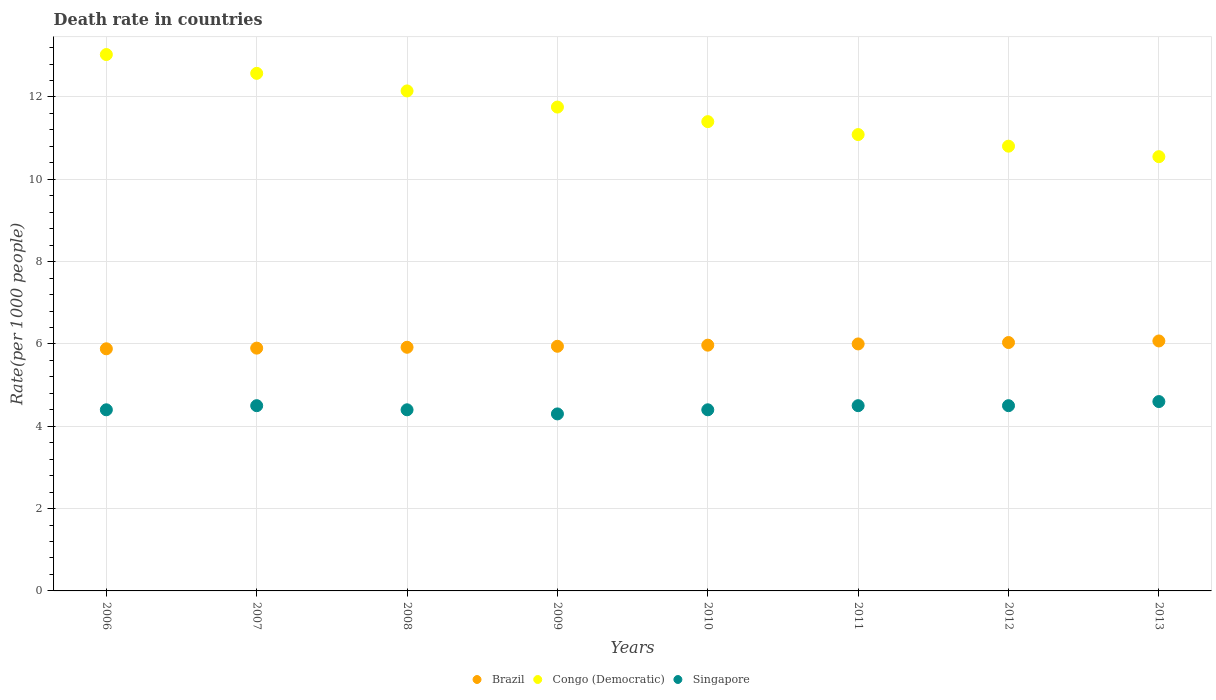How many different coloured dotlines are there?
Keep it short and to the point. 3. Is the number of dotlines equal to the number of legend labels?
Offer a terse response. Yes. What is the death rate in Singapore in 2012?
Your answer should be very brief. 4.5. Across all years, what is the maximum death rate in Congo (Democratic)?
Offer a very short reply. 13.03. Across all years, what is the minimum death rate in Brazil?
Give a very brief answer. 5.88. In which year was the death rate in Congo (Democratic) maximum?
Your answer should be very brief. 2006. What is the total death rate in Brazil in the graph?
Offer a very short reply. 47.72. What is the difference between the death rate in Brazil in 2010 and that in 2013?
Make the answer very short. -0.1. What is the difference between the death rate in Brazil in 2006 and the death rate in Congo (Democratic) in 2013?
Give a very brief answer. -4.67. What is the average death rate in Brazil per year?
Offer a very short reply. 5.96. In the year 2008, what is the difference between the death rate in Singapore and death rate in Congo (Democratic)?
Give a very brief answer. -7.75. In how many years, is the death rate in Singapore greater than 8.4?
Offer a very short reply. 0. What is the ratio of the death rate in Congo (Democratic) in 2006 to that in 2008?
Keep it short and to the point. 1.07. Is the difference between the death rate in Singapore in 2008 and 2012 greater than the difference between the death rate in Congo (Democratic) in 2008 and 2012?
Your answer should be compact. No. What is the difference between the highest and the second highest death rate in Congo (Democratic)?
Keep it short and to the point. 0.46. What is the difference between the highest and the lowest death rate in Brazil?
Ensure brevity in your answer.  0.19. Is the sum of the death rate in Congo (Democratic) in 2006 and 2009 greater than the maximum death rate in Brazil across all years?
Ensure brevity in your answer.  Yes. Does the death rate in Singapore monotonically increase over the years?
Provide a short and direct response. No. How many dotlines are there?
Make the answer very short. 3. What is the difference between two consecutive major ticks on the Y-axis?
Provide a succinct answer. 2. Where does the legend appear in the graph?
Keep it short and to the point. Bottom center. How are the legend labels stacked?
Your answer should be very brief. Horizontal. What is the title of the graph?
Offer a terse response. Death rate in countries. Does "Europe(developing only)" appear as one of the legend labels in the graph?
Ensure brevity in your answer.  No. What is the label or title of the X-axis?
Keep it short and to the point. Years. What is the label or title of the Y-axis?
Your response must be concise. Rate(per 1000 people). What is the Rate(per 1000 people) in Brazil in 2006?
Make the answer very short. 5.88. What is the Rate(per 1000 people) of Congo (Democratic) in 2006?
Your answer should be compact. 13.03. What is the Rate(per 1000 people) in Singapore in 2006?
Offer a terse response. 4.4. What is the Rate(per 1000 people) in Brazil in 2007?
Your response must be concise. 5.9. What is the Rate(per 1000 people) in Congo (Democratic) in 2007?
Provide a succinct answer. 12.57. What is the Rate(per 1000 people) of Singapore in 2007?
Your response must be concise. 4.5. What is the Rate(per 1000 people) in Brazil in 2008?
Keep it short and to the point. 5.92. What is the Rate(per 1000 people) in Congo (Democratic) in 2008?
Keep it short and to the point. 12.15. What is the Rate(per 1000 people) in Brazil in 2009?
Offer a terse response. 5.94. What is the Rate(per 1000 people) of Congo (Democratic) in 2009?
Offer a very short reply. 11.75. What is the Rate(per 1000 people) in Singapore in 2009?
Offer a very short reply. 4.3. What is the Rate(per 1000 people) in Brazil in 2010?
Your answer should be very brief. 5.97. What is the Rate(per 1000 people) of Congo (Democratic) in 2010?
Your answer should be compact. 11.4. What is the Rate(per 1000 people) in Singapore in 2010?
Ensure brevity in your answer.  4.4. What is the Rate(per 1000 people) of Congo (Democratic) in 2011?
Ensure brevity in your answer.  11.09. What is the Rate(per 1000 people) of Singapore in 2011?
Your response must be concise. 4.5. What is the Rate(per 1000 people) of Brazil in 2012?
Keep it short and to the point. 6.03. What is the Rate(per 1000 people) of Congo (Democratic) in 2012?
Make the answer very short. 10.8. What is the Rate(per 1000 people) of Brazil in 2013?
Provide a short and direct response. 6.07. What is the Rate(per 1000 people) in Congo (Democratic) in 2013?
Provide a short and direct response. 10.55. Across all years, what is the maximum Rate(per 1000 people) in Brazil?
Give a very brief answer. 6.07. Across all years, what is the maximum Rate(per 1000 people) in Congo (Democratic)?
Give a very brief answer. 13.03. Across all years, what is the minimum Rate(per 1000 people) in Brazil?
Make the answer very short. 5.88. Across all years, what is the minimum Rate(per 1000 people) of Congo (Democratic)?
Your response must be concise. 10.55. Across all years, what is the minimum Rate(per 1000 people) of Singapore?
Offer a very short reply. 4.3. What is the total Rate(per 1000 people) in Brazil in the graph?
Ensure brevity in your answer.  47.72. What is the total Rate(per 1000 people) in Congo (Democratic) in the graph?
Offer a terse response. 93.34. What is the total Rate(per 1000 people) of Singapore in the graph?
Offer a terse response. 35.6. What is the difference between the Rate(per 1000 people) of Brazil in 2006 and that in 2007?
Offer a terse response. -0.02. What is the difference between the Rate(per 1000 people) in Congo (Democratic) in 2006 and that in 2007?
Make the answer very short. 0.46. What is the difference between the Rate(per 1000 people) of Brazil in 2006 and that in 2008?
Your answer should be very brief. -0.04. What is the difference between the Rate(per 1000 people) in Congo (Democratic) in 2006 and that in 2008?
Your answer should be very brief. 0.88. What is the difference between the Rate(per 1000 people) in Brazil in 2006 and that in 2009?
Offer a very short reply. -0.06. What is the difference between the Rate(per 1000 people) in Congo (Democratic) in 2006 and that in 2009?
Keep it short and to the point. 1.28. What is the difference between the Rate(per 1000 people) of Brazil in 2006 and that in 2010?
Your response must be concise. -0.09. What is the difference between the Rate(per 1000 people) in Congo (Democratic) in 2006 and that in 2010?
Provide a succinct answer. 1.63. What is the difference between the Rate(per 1000 people) of Brazil in 2006 and that in 2011?
Give a very brief answer. -0.12. What is the difference between the Rate(per 1000 people) in Congo (Democratic) in 2006 and that in 2011?
Your answer should be very brief. 1.94. What is the difference between the Rate(per 1000 people) in Brazil in 2006 and that in 2012?
Your answer should be compact. -0.15. What is the difference between the Rate(per 1000 people) in Congo (Democratic) in 2006 and that in 2012?
Ensure brevity in your answer.  2.23. What is the difference between the Rate(per 1000 people) of Singapore in 2006 and that in 2012?
Offer a terse response. -0.1. What is the difference between the Rate(per 1000 people) in Brazil in 2006 and that in 2013?
Give a very brief answer. -0.19. What is the difference between the Rate(per 1000 people) in Congo (Democratic) in 2006 and that in 2013?
Provide a short and direct response. 2.48. What is the difference between the Rate(per 1000 people) in Brazil in 2007 and that in 2008?
Give a very brief answer. -0.02. What is the difference between the Rate(per 1000 people) of Congo (Democratic) in 2007 and that in 2008?
Provide a succinct answer. 0.43. What is the difference between the Rate(per 1000 people) in Brazil in 2007 and that in 2009?
Give a very brief answer. -0.04. What is the difference between the Rate(per 1000 people) of Congo (Democratic) in 2007 and that in 2009?
Provide a succinct answer. 0.82. What is the difference between the Rate(per 1000 people) of Singapore in 2007 and that in 2009?
Give a very brief answer. 0.2. What is the difference between the Rate(per 1000 people) of Brazil in 2007 and that in 2010?
Ensure brevity in your answer.  -0.07. What is the difference between the Rate(per 1000 people) in Congo (Democratic) in 2007 and that in 2010?
Ensure brevity in your answer.  1.17. What is the difference between the Rate(per 1000 people) in Singapore in 2007 and that in 2010?
Make the answer very short. 0.1. What is the difference between the Rate(per 1000 people) of Brazil in 2007 and that in 2011?
Ensure brevity in your answer.  -0.1. What is the difference between the Rate(per 1000 people) of Congo (Democratic) in 2007 and that in 2011?
Your answer should be very brief. 1.49. What is the difference between the Rate(per 1000 people) of Singapore in 2007 and that in 2011?
Your answer should be compact. 0. What is the difference between the Rate(per 1000 people) of Brazil in 2007 and that in 2012?
Your answer should be compact. -0.14. What is the difference between the Rate(per 1000 people) in Congo (Democratic) in 2007 and that in 2012?
Ensure brevity in your answer.  1.77. What is the difference between the Rate(per 1000 people) of Brazil in 2007 and that in 2013?
Provide a succinct answer. -0.17. What is the difference between the Rate(per 1000 people) in Congo (Democratic) in 2007 and that in 2013?
Ensure brevity in your answer.  2.02. What is the difference between the Rate(per 1000 people) in Brazil in 2008 and that in 2009?
Your answer should be compact. -0.02. What is the difference between the Rate(per 1000 people) in Congo (Democratic) in 2008 and that in 2009?
Give a very brief answer. 0.39. What is the difference between the Rate(per 1000 people) in Singapore in 2008 and that in 2009?
Offer a terse response. 0.1. What is the difference between the Rate(per 1000 people) in Brazil in 2008 and that in 2010?
Give a very brief answer. -0.05. What is the difference between the Rate(per 1000 people) in Congo (Democratic) in 2008 and that in 2010?
Give a very brief answer. 0.75. What is the difference between the Rate(per 1000 people) in Brazil in 2008 and that in 2011?
Your response must be concise. -0.08. What is the difference between the Rate(per 1000 people) of Congo (Democratic) in 2008 and that in 2011?
Your response must be concise. 1.06. What is the difference between the Rate(per 1000 people) of Singapore in 2008 and that in 2011?
Your answer should be compact. -0.1. What is the difference between the Rate(per 1000 people) in Brazil in 2008 and that in 2012?
Your response must be concise. -0.12. What is the difference between the Rate(per 1000 people) of Congo (Democratic) in 2008 and that in 2012?
Offer a terse response. 1.34. What is the difference between the Rate(per 1000 people) of Brazil in 2008 and that in 2013?
Offer a terse response. -0.15. What is the difference between the Rate(per 1000 people) of Congo (Democratic) in 2008 and that in 2013?
Offer a terse response. 1.6. What is the difference between the Rate(per 1000 people) in Brazil in 2009 and that in 2010?
Offer a very short reply. -0.03. What is the difference between the Rate(per 1000 people) in Congo (Democratic) in 2009 and that in 2010?
Offer a very short reply. 0.35. What is the difference between the Rate(per 1000 people) in Brazil in 2009 and that in 2011?
Provide a succinct answer. -0.06. What is the difference between the Rate(per 1000 people) in Congo (Democratic) in 2009 and that in 2011?
Provide a short and direct response. 0.67. What is the difference between the Rate(per 1000 people) in Singapore in 2009 and that in 2011?
Offer a very short reply. -0.2. What is the difference between the Rate(per 1000 people) in Brazil in 2009 and that in 2012?
Provide a succinct answer. -0.09. What is the difference between the Rate(per 1000 people) in Singapore in 2009 and that in 2012?
Your answer should be compact. -0.2. What is the difference between the Rate(per 1000 people) of Brazil in 2009 and that in 2013?
Ensure brevity in your answer.  -0.13. What is the difference between the Rate(per 1000 people) of Congo (Democratic) in 2009 and that in 2013?
Your answer should be very brief. 1.21. What is the difference between the Rate(per 1000 people) of Singapore in 2009 and that in 2013?
Keep it short and to the point. -0.3. What is the difference between the Rate(per 1000 people) in Brazil in 2010 and that in 2011?
Keep it short and to the point. -0.03. What is the difference between the Rate(per 1000 people) in Congo (Democratic) in 2010 and that in 2011?
Offer a terse response. 0.31. What is the difference between the Rate(per 1000 people) of Brazil in 2010 and that in 2012?
Provide a succinct answer. -0.06. What is the difference between the Rate(per 1000 people) in Congo (Democratic) in 2010 and that in 2012?
Your answer should be very brief. 0.6. What is the difference between the Rate(per 1000 people) in Singapore in 2010 and that in 2012?
Make the answer very short. -0.1. What is the difference between the Rate(per 1000 people) in Brazil in 2010 and that in 2013?
Offer a very short reply. -0.1. What is the difference between the Rate(per 1000 people) of Congo (Democratic) in 2010 and that in 2013?
Offer a terse response. 0.85. What is the difference between the Rate(per 1000 people) in Brazil in 2011 and that in 2012?
Provide a succinct answer. -0.03. What is the difference between the Rate(per 1000 people) in Congo (Democratic) in 2011 and that in 2012?
Provide a short and direct response. 0.28. What is the difference between the Rate(per 1000 people) of Singapore in 2011 and that in 2012?
Your response must be concise. 0. What is the difference between the Rate(per 1000 people) of Brazil in 2011 and that in 2013?
Keep it short and to the point. -0.07. What is the difference between the Rate(per 1000 people) in Congo (Democratic) in 2011 and that in 2013?
Your answer should be very brief. 0.54. What is the difference between the Rate(per 1000 people) in Singapore in 2011 and that in 2013?
Give a very brief answer. -0.1. What is the difference between the Rate(per 1000 people) of Brazil in 2012 and that in 2013?
Provide a succinct answer. -0.04. What is the difference between the Rate(per 1000 people) of Congo (Democratic) in 2012 and that in 2013?
Provide a short and direct response. 0.26. What is the difference between the Rate(per 1000 people) of Singapore in 2012 and that in 2013?
Provide a short and direct response. -0.1. What is the difference between the Rate(per 1000 people) in Brazil in 2006 and the Rate(per 1000 people) in Congo (Democratic) in 2007?
Provide a succinct answer. -6.69. What is the difference between the Rate(per 1000 people) in Brazil in 2006 and the Rate(per 1000 people) in Singapore in 2007?
Give a very brief answer. 1.38. What is the difference between the Rate(per 1000 people) of Congo (Democratic) in 2006 and the Rate(per 1000 people) of Singapore in 2007?
Provide a succinct answer. 8.53. What is the difference between the Rate(per 1000 people) in Brazil in 2006 and the Rate(per 1000 people) in Congo (Democratic) in 2008?
Offer a very short reply. -6.26. What is the difference between the Rate(per 1000 people) in Brazil in 2006 and the Rate(per 1000 people) in Singapore in 2008?
Provide a succinct answer. 1.48. What is the difference between the Rate(per 1000 people) of Congo (Democratic) in 2006 and the Rate(per 1000 people) of Singapore in 2008?
Offer a very short reply. 8.63. What is the difference between the Rate(per 1000 people) of Brazil in 2006 and the Rate(per 1000 people) of Congo (Democratic) in 2009?
Offer a very short reply. -5.87. What is the difference between the Rate(per 1000 people) of Brazil in 2006 and the Rate(per 1000 people) of Singapore in 2009?
Your answer should be compact. 1.58. What is the difference between the Rate(per 1000 people) in Congo (Democratic) in 2006 and the Rate(per 1000 people) in Singapore in 2009?
Your answer should be compact. 8.73. What is the difference between the Rate(per 1000 people) in Brazil in 2006 and the Rate(per 1000 people) in Congo (Democratic) in 2010?
Your response must be concise. -5.52. What is the difference between the Rate(per 1000 people) of Brazil in 2006 and the Rate(per 1000 people) of Singapore in 2010?
Make the answer very short. 1.48. What is the difference between the Rate(per 1000 people) in Congo (Democratic) in 2006 and the Rate(per 1000 people) in Singapore in 2010?
Your answer should be compact. 8.63. What is the difference between the Rate(per 1000 people) in Brazil in 2006 and the Rate(per 1000 people) in Congo (Democratic) in 2011?
Offer a very short reply. -5.2. What is the difference between the Rate(per 1000 people) in Brazil in 2006 and the Rate(per 1000 people) in Singapore in 2011?
Keep it short and to the point. 1.38. What is the difference between the Rate(per 1000 people) in Congo (Democratic) in 2006 and the Rate(per 1000 people) in Singapore in 2011?
Provide a succinct answer. 8.53. What is the difference between the Rate(per 1000 people) of Brazil in 2006 and the Rate(per 1000 people) of Congo (Democratic) in 2012?
Ensure brevity in your answer.  -4.92. What is the difference between the Rate(per 1000 people) of Brazil in 2006 and the Rate(per 1000 people) of Singapore in 2012?
Give a very brief answer. 1.38. What is the difference between the Rate(per 1000 people) of Congo (Democratic) in 2006 and the Rate(per 1000 people) of Singapore in 2012?
Offer a terse response. 8.53. What is the difference between the Rate(per 1000 people) of Brazil in 2006 and the Rate(per 1000 people) of Congo (Democratic) in 2013?
Your answer should be compact. -4.67. What is the difference between the Rate(per 1000 people) of Brazil in 2006 and the Rate(per 1000 people) of Singapore in 2013?
Provide a short and direct response. 1.28. What is the difference between the Rate(per 1000 people) of Congo (Democratic) in 2006 and the Rate(per 1000 people) of Singapore in 2013?
Your response must be concise. 8.43. What is the difference between the Rate(per 1000 people) of Brazil in 2007 and the Rate(per 1000 people) of Congo (Democratic) in 2008?
Offer a terse response. -6.25. What is the difference between the Rate(per 1000 people) in Brazil in 2007 and the Rate(per 1000 people) in Singapore in 2008?
Provide a short and direct response. 1.5. What is the difference between the Rate(per 1000 people) in Congo (Democratic) in 2007 and the Rate(per 1000 people) in Singapore in 2008?
Your answer should be compact. 8.17. What is the difference between the Rate(per 1000 people) of Brazil in 2007 and the Rate(per 1000 people) of Congo (Democratic) in 2009?
Give a very brief answer. -5.86. What is the difference between the Rate(per 1000 people) in Brazil in 2007 and the Rate(per 1000 people) in Singapore in 2009?
Offer a terse response. 1.6. What is the difference between the Rate(per 1000 people) of Congo (Democratic) in 2007 and the Rate(per 1000 people) of Singapore in 2009?
Offer a very short reply. 8.27. What is the difference between the Rate(per 1000 people) of Brazil in 2007 and the Rate(per 1000 people) of Congo (Democratic) in 2010?
Offer a very short reply. -5.5. What is the difference between the Rate(per 1000 people) of Brazil in 2007 and the Rate(per 1000 people) of Singapore in 2010?
Provide a succinct answer. 1.5. What is the difference between the Rate(per 1000 people) of Congo (Democratic) in 2007 and the Rate(per 1000 people) of Singapore in 2010?
Offer a terse response. 8.17. What is the difference between the Rate(per 1000 people) of Brazil in 2007 and the Rate(per 1000 people) of Congo (Democratic) in 2011?
Keep it short and to the point. -5.19. What is the difference between the Rate(per 1000 people) of Brazil in 2007 and the Rate(per 1000 people) of Singapore in 2011?
Provide a succinct answer. 1.4. What is the difference between the Rate(per 1000 people) in Congo (Democratic) in 2007 and the Rate(per 1000 people) in Singapore in 2011?
Provide a short and direct response. 8.07. What is the difference between the Rate(per 1000 people) of Brazil in 2007 and the Rate(per 1000 people) of Congo (Democratic) in 2012?
Your answer should be very brief. -4.91. What is the difference between the Rate(per 1000 people) of Brazil in 2007 and the Rate(per 1000 people) of Singapore in 2012?
Give a very brief answer. 1.4. What is the difference between the Rate(per 1000 people) in Congo (Democratic) in 2007 and the Rate(per 1000 people) in Singapore in 2012?
Make the answer very short. 8.07. What is the difference between the Rate(per 1000 people) in Brazil in 2007 and the Rate(per 1000 people) in Congo (Democratic) in 2013?
Ensure brevity in your answer.  -4.65. What is the difference between the Rate(per 1000 people) of Brazil in 2007 and the Rate(per 1000 people) of Singapore in 2013?
Provide a short and direct response. 1.3. What is the difference between the Rate(per 1000 people) of Congo (Democratic) in 2007 and the Rate(per 1000 people) of Singapore in 2013?
Ensure brevity in your answer.  7.97. What is the difference between the Rate(per 1000 people) of Brazil in 2008 and the Rate(per 1000 people) of Congo (Democratic) in 2009?
Ensure brevity in your answer.  -5.83. What is the difference between the Rate(per 1000 people) of Brazil in 2008 and the Rate(per 1000 people) of Singapore in 2009?
Offer a very short reply. 1.62. What is the difference between the Rate(per 1000 people) in Congo (Democratic) in 2008 and the Rate(per 1000 people) in Singapore in 2009?
Offer a very short reply. 7.85. What is the difference between the Rate(per 1000 people) of Brazil in 2008 and the Rate(per 1000 people) of Congo (Democratic) in 2010?
Provide a succinct answer. -5.48. What is the difference between the Rate(per 1000 people) in Brazil in 2008 and the Rate(per 1000 people) in Singapore in 2010?
Provide a succinct answer. 1.52. What is the difference between the Rate(per 1000 people) in Congo (Democratic) in 2008 and the Rate(per 1000 people) in Singapore in 2010?
Your answer should be very brief. 7.75. What is the difference between the Rate(per 1000 people) in Brazil in 2008 and the Rate(per 1000 people) in Congo (Democratic) in 2011?
Your answer should be compact. -5.17. What is the difference between the Rate(per 1000 people) in Brazil in 2008 and the Rate(per 1000 people) in Singapore in 2011?
Provide a succinct answer. 1.42. What is the difference between the Rate(per 1000 people) in Congo (Democratic) in 2008 and the Rate(per 1000 people) in Singapore in 2011?
Offer a terse response. 7.65. What is the difference between the Rate(per 1000 people) in Brazil in 2008 and the Rate(per 1000 people) in Congo (Democratic) in 2012?
Your answer should be very brief. -4.88. What is the difference between the Rate(per 1000 people) in Brazil in 2008 and the Rate(per 1000 people) in Singapore in 2012?
Keep it short and to the point. 1.42. What is the difference between the Rate(per 1000 people) of Congo (Democratic) in 2008 and the Rate(per 1000 people) of Singapore in 2012?
Your answer should be compact. 7.65. What is the difference between the Rate(per 1000 people) of Brazil in 2008 and the Rate(per 1000 people) of Congo (Democratic) in 2013?
Your answer should be very brief. -4.63. What is the difference between the Rate(per 1000 people) of Brazil in 2008 and the Rate(per 1000 people) of Singapore in 2013?
Give a very brief answer. 1.32. What is the difference between the Rate(per 1000 people) of Congo (Democratic) in 2008 and the Rate(per 1000 people) of Singapore in 2013?
Your response must be concise. 7.55. What is the difference between the Rate(per 1000 people) in Brazil in 2009 and the Rate(per 1000 people) in Congo (Democratic) in 2010?
Your answer should be very brief. -5.46. What is the difference between the Rate(per 1000 people) of Brazil in 2009 and the Rate(per 1000 people) of Singapore in 2010?
Your response must be concise. 1.54. What is the difference between the Rate(per 1000 people) of Congo (Democratic) in 2009 and the Rate(per 1000 people) of Singapore in 2010?
Provide a succinct answer. 7.35. What is the difference between the Rate(per 1000 people) of Brazil in 2009 and the Rate(per 1000 people) of Congo (Democratic) in 2011?
Offer a very short reply. -5.14. What is the difference between the Rate(per 1000 people) in Brazil in 2009 and the Rate(per 1000 people) in Singapore in 2011?
Ensure brevity in your answer.  1.44. What is the difference between the Rate(per 1000 people) of Congo (Democratic) in 2009 and the Rate(per 1000 people) of Singapore in 2011?
Offer a terse response. 7.25. What is the difference between the Rate(per 1000 people) in Brazil in 2009 and the Rate(per 1000 people) in Congo (Democratic) in 2012?
Offer a very short reply. -4.86. What is the difference between the Rate(per 1000 people) in Brazil in 2009 and the Rate(per 1000 people) in Singapore in 2012?
Ensure brevity in your answer.  1.44. What is the difference between the Rate(per 1000 people) of Congo (Democratic) in 2009 and the Rate(per 1000 people) of Singapore in 2012?
Provide a succinct answer. 7.25. What is the difference between the Rate(per 1000 people) in Brazil in 2009 and the Rate(per 1000 people) in Congo (Democratic) in 2013?
Your answer should be very brief. -4.61. What is the difference between the Rate(per 1000 people) of Brazil in 2009 and the Rate(per 1000 people) of Singapore in 2013?
Your response must be concise. 1.34. What is the difference between the Rate(per 1000 people) in Congo (Democratic) in 2009 and the Rate(per 1000 people) in Singapore in 2013?
Offer a very short reply. 7.15. What is the difference between the Rate(per 1000 people) in Brazil in 2010 and the Rate(per 1000 people) in Congo (Democratic) in 2011?
Make the answer very short. -5.12. What is the difference between the Rate(per 1000 people) of Brazil in 2010 and the Rate(per 1000 people) of Singapore in 2011?
Your answer should be very brief. 1.47. What is the difference between the Rate(per 1000 people) of Brazil in 2010 and the Rate(per 1000 people) of Congo (Democratic) in 2012?
Your answer should be compact. -4.83. What is the difference between the Rate(per 1000 people) of Brazil in 2010 and the Rate(per 1000 people) of Singapore in 2012?
Your answer should be very brief. 1.47. What is the difference between the Rate(per 1000 people) in Brazil in 2010 and the Rate(per 1000 people) in Congo (Democratic) in 2013?
Your answer should be compact. -4.58. What is the difference between the Rate(per 1000 people) in Brazil in 2010 and the Rate(per 1000 people) in Singapore in 2013?
Provide a short and direct response. 1.37. What is the difference between the Rate(per 1000 people) of Congo (Democratic) in 2010 and the Rate(per 1000 people) of Singapore in 2013?
Provide a short and direct response. 6.8. What is the difference between the Rate(per 1000 people) of Brazil in 2011 and the Rate(per 1000 people) of Congo (Democratic) in 2012?
Your answer should be compact. -4.8. What is the difference between the Rate(per 1000 people) in Congo (Democratic) in 2011 and the Rate(per 1000 people) in Singapore in 2012?
Ensure brevity in your answer.  6.59. What is the difference between the Rate(per 1000 people) of Brazil in 2011 and the Rate(per 1000 people) of Congo (Democratic) in 2013?
Provide a short and direct response. -4.55. What is the difference between the Rate(per 1000 people) of Congo (Democratic) in 2011 and the Rate(per 1000 people) of Singapore in 2013?
Ensure brevity in your answer.  6.49. What is the difference between the Rate(per 1000 people) of Brazil in 2012 and the Rate(per 1000 people) of Congo (Democratic) in 2013?
Offer a very short reply. -4.51. What is the difference between the Rate(per 1000 people) of Brazil in 2012 and the Rate(per 1000 people) of Singapore in 2013?
Make the answer very short. 1.43. What is the difference between the Rate(per 1000 people) in Congo (Democratic) in 2012 and the Rate(per 1000 people) in Singapore in 2013?
Your answer should be very brief. 6.2. What is the average Rate(per 1000 people) in Brazil per year?
Give a very brief answer. 5.96. What is the average Rate(per 1000 people) of Congo (Democratic) per year?
Ensure brevity in your answer.  11.67. What is the average Rate(per 1000 people) of Singapore per year?
Give a very brief answer. 4.45. In the year 2006, what is the difference between the Rate(per 1000 people) of Brazil and Rate(per 1000 people) of Congo (Democratic)?
Give a very brief answer. -7.15. In the year 2006, what is the difference between the Rate(per 1000 people) in Brazil and Rate(per 1000 people) in Singapore?
Make the answer very short. 1.48. In the year 2006, what is the difference between the Rate(per 1000 people) in Congo (Democratic) and Rate(per 1000 people) in Singapore?
Keep it short and to the point. 8.63. In the year 2007, what is the difference between the Rate(per 1000 people) of Brazil and Rate(per 1000 people) of Congo (Democratic)?
Provide a short and direct response. -6.67. In the year 2007, what is the difference between the Rate(per 1000 people) in Brazil and Rate(per 1000 people) in Singapore?
Your response must be concise. 1.4. In the year 2007, what is the difference between the Rate(per 1000 people) of Congo (Democratic) and Rate(per 1000 people) of Singapore?
Give a very brief answer. 8.07. In the year 2008, what is the difference between the Rate(per 1000 people) of Brazil and Rate(per 1000 people) of Congo (Democratic)?
Offer a very short reply. -6.23. In the year 2008, what is the difference between the Rate(per 1000 people) of Brazil and Rate(per 1000 people) of Singapore?
Provide a succinct answer. 1.52. In the year 2008, what is the difference between the Rate(per 1000 people) of Congo (Democratic) and Rate(per 1000 people) of Singapore?
Keep it short and to the point. 7.75. In the year 2009, what is the difference between the Rate(per 1000 people) in Brazil and Rate(per 1000 people) in Congo (Democratic)?
Offer a very short reply. -5.81. In the year 2009, what is the difference between the Rate(per 1000 people) in Brazil and Rate(per 1000 people) in Singapore?
Your response must be concise. 1.64. In the year 2009, what is the difference between the Rate(per 1000 people) of Congo (Democratic) and Rate(per 1000 people) of Singapore?
Your response must be concise. 7.45. In the year 2010, what is the difference between the Rate(per 1000 people) in Brazil and Rate(per 1000 people) in Congo (Democratic)?
Your answer should be compact. -5.43. In the year 2010, what is the difference between the Rate(per 1000 people) of Brazil and Rate(per 1000 people) of Singapore?
Give a very brief answer. 1.57. In the year 2010, what is the difference between the Rate(per 1000 people) of Congo (Democratic) and Rate(per 1000 people) of Singapore?
Offer a terse response. 7. In the year 2011, what is the difference between the Rate(per 1000 people) in Brazil and Rate(per 1000 people) in Congo (Democratic)?
Your answer should be compact. -5.09. In the year 2011, what is the difference between the Rate(per 1000 people) in Brazil and Rate(per 1000 people) in Singapore?
Make the answer very short. 1.5. In the year 2011, what is the difference between the Rate(per 1000 people) in Congo (Democratic) and Rate(per 1000 people) in Singapore?
Your response must be concise. 6.59. In the year 2012, what is the difference between the Rate(per 1000 people) of Brazil and Rate(per 1000 people) of Congo (Democratic)?
Offer a terse response. -4.77. In the year 2012, what is the difference between the Rate(per 1000 people) of Brazil and Rate(per 1000 people) of Singapore?
Your answer should be very brief. 1.53. In the year 2012, what is the difference between the Rate(per 1000 people) of Congo (Democratic) and Rate(per 1000 people) of Singapore?
Provide a short and direct response. 6.3. In the year 2013, what is the difference between the Rate(per 1000 people) in Brazil and Rate(per 1000 people) in Congo (Democratic)?
Offer a terse response. -4.48. In the year 2013, what is the difference between the Rate(per 1000 people) in Brazil and Rate(per 1000 people) in Singapore?
Ensure brevity in your answer.  1.47. In the year 2013, what is the difference between the Rate(per 1000 people) in Congo (Democratic) and Rate(per 1000 people) in Singapore?
Your answer should be very brief. 5.95. What is the ratio of the Rate(per 1000 people) in Brazil in 2006 to that in 2007?
Ensure brevity in your answer.  1. What is the ratio of the Rate(per 1000 people) of Congo (Democratic) in 2006 to that in 2007?
Provide a succinct answer. 1.04. What is the ratio of the Rate(per 1000 people) in Singapore in 2006 to that in 2007?
Your answer should be compact. 0.98. What is the ratio of the Rate(per 1000 people) in Congo (Democratic) in 2006 to that in 2008?
Make the answer very short. 1.07. What is the ratio of the Rate(per 1000 people) of Brazil in 2006 to that in 2009?
Your response must be concise. 0.99. What is the ratio of the Rate(per 1000 people) of Congo (Democratic) in 2006 to that in 2009?
Ensure brevity in your answer.  1.11. What is the ratio of the Rate(per 1000 people) of Singapore in 2006 to that in 2009?
Your response must be concise. 1.02. What is the ratio of the Rate(per 1000 people) in Brazil in 2006 to that in 2010?
Your response must be concise. 0.99. What is the ratio of the Rate(per 1000 people) in Congo (Democratic) in 2006 to that in 2010?
Your answer should be compact. 1.14. What is the ratio of the Rate(per 1000 people) in Singapore in 2006 to that in 2010?
Give a very brief answer. 1. What is the ratio of the Rate(per 1000 people) of Brazil in 2006 to that in 2011?
Offer a very short reply. 0.98. What is the ratio of the Rate(per 1000 people) in Congo (Democratic) in 2006 to that in 2011?
Make the answer very short. 1.18. What is the ratio of the Rate(per 1000 people) in Singapore in 2006 to that in 2011?
Your answer should be very brief. 0.98. What is the ratio of the Rate(per 1000 people) of Brazil in 2006 to that in 2012?
Your response must be concise. 0.97. What is the ratio of the Rate(per 1000 people) of Congo (Democratic) in 2006 to that in 2012?
Make the answer very short. 1.21. What is the ratio of the Rate(per 1000 people) of Singapore in 2006 to that in 2012?
Offer a very short reply. 0.98. What is the ratio of the Rate(per 1000 people) of Brazil in 2006 to that in 2013?
Provide a succinct answer. 0.97. What is the ratio of the Rate(per 1000 people) of Congo (Democratic) in 2006 to that in 2013?
Make the answer very short. 1.24. What is the ratio of the Rate(per 1000 people) of Singapore in 2006 to that in 2013?
Offer a very short reply. 0.96. What is the ratio of the Rate(per 1000 people) of Congo (Democratic) in 2007 to that in 2008?
Give a very brief answer. 1.04. What is the ratio of the Rate(per 1000 people) in Singapore in 2007 to that in 2008?
Offer a terse response. 1.02. What is the ratio of the Rate(per 1000 people) in Congo (Democratic) in 2007 to that in 2009?
Your answer should be very brief. 1.07. What is the ratio of the Rate(per 1000 people) in Singapore in 2007 to that in 2009?
Keep it short and to the point. 1.05. What is the ratio of the Rate(per 1000 people) in Brazil in 2007 to that in 2010?
Provide a succinct answer. 0.99. What is the ratio of the Rate(per 1000 people) of Congo (Democratic) in 2007 to that in 2010?
Give a very brief answer. 1.1. What is the ratio of the Rate(per 1000 people) in Singapore in 2007 to that in 2010?
Provide a succinct answer. 1.02. What is the ratio of the Rate(per 1000 people) of Brazil in 2007 to that in 2011?
Offer a very short reply. 0.98. What is the ratio of the Rate(per 1000 people) of Congo (Democratic) in 2007 to that in 2011?
Provide a succinct answer. 1.13. What is the ratio of the Rate(per 1000 people) of Brazil in 2007 to that in 2012?
Provide a succinct answer. 0.98. What is the ratio of the Rate(per 1000 people) in Congo (Democratic) in 2007 to that in 2012?
Provide a short and direct response. 1.16. What is the ratio of the Rate(per 1000 people) of Brazil in 2007 to that in 2013?
Ensure brevity in your answer.  0.97. What is the ratio of the Rate(per 1000 people) in Congo (Democratic) in 2007 to that in 2013?
Give a very brief answer. 1.19. What is the ratio of the Rate(per 1000 people) in Singapore in 2007 to that in 2013?
Give a very brief answer. 0.98. What is the ratio of the Rate(per 1000 people) of Brazil in 2008 to that in 2009?
Offer a very short reply. 1. What is the ratio of the Rate(per 1000 people) in Congo (Democratic) in 2008 to that in 2009?
Make the answer very short. 1.03. What is the ratio of the Rate(per 1000 people) in Singapore in 2008 to that in 2009?
Your answer should be very brief. 1.02. What is the ratio of the Rate(per 1000 people) in Brazil in 2008 to that in 2010?
Provide a succinct answer. 0.99. What is the ratio of the Rate(per 1000 people) of Congo (Democratic) in 2008 to that in 2010?
Make the answer very short. 1.07. What is the ratio of the Rate(per 1000 people) of Singapore in 2008 to that in 2010?
Your response must be concise. 1. What is the ratio of the Rate(per 1000 people) in Brazil in 2008 to that in 2011?
Your answer should be very brief. 0.99. What is the ratio of the Rate(per 1000 people) in Congo (Democratic) in 2008 to that in 2011?
Your response must be concise. 1.1. What is the ratio of the Rate(per 1000 people) of Singapore in 2008 to that in 2011?
Your answer should be very brief. 0.98. What is the ratio of the Rate(per 1000 people) of Brazil in 2008 to that in 2012?
Ensure brevity in your answer.  0.98. What is the ratio of the Rate(per 1000 people) in Congo (Democratic) in 2008 to that in 2012?
Ensure brevity in your answer.  1.12. What is the ratio of the Rate(per 1000 people) of Singapore in 2008 to that in 2012?
Your answer should be compact. 0.98. What is the ratio of the Rate(per 1000 people) of Brazil in 2008 to that in 2013?
Make the answer very short. 0.97. What is the ratio of the Rate(per 1000 people) of Congo (Democratic) in 2008 to that in 2013?
Keep it short and to the point. 1.15. What is the ratio of the Rate(per 1000 people) in Singapore in 2008 to that in 2013?
Make the answer very short. 0.96. What is the ratio of the Rate(per 1000 people) in Congo (Democratic) in 2009 to that in 2010?
Ensure brevity in your answer.  1.03. What is the ratio of the Rate(per 1000 people) in Singapore in 2009 to that in 2010?
Your response must be concise. 0.98. What is the ratio of the Rate(per 1000 people) of Congo (Democratic) in 2009 to that in 2011?
Offer a very short reply. 1.06. What is the ratio of the Rate(per 1000 people) of Singapore in 2009 to that in 2011?
Your response must be concise. 0.96. What is the ratio of the Rate(per 1000 people) in Brazil in 2009 to that in 2012?
Your answer should be compact. 0.98. What is the ratio of the Rate(per 1000 people) in Congo (Democratic) in 2009 to that in 2012?
Offer a very short reply. 1.09. What is the ratio of the Rate(per 1000 people) of Singapore in 2009 to that in 2012?
Your answer should be compact. 0.96. What is the ratio of the Rate(per 1000 people) in Brazil in 2009 to that in 2013?
Make the answer very short. 0.98. What is the ratio of the Rate(per 1000 people) in Congo (Democratic) in 2009 to that in 2013?
Provide a succinct answer. 1.11. What is the ratio of the Rate(per 1000 people) of Singapore in 2009 to that in 2013?
Offer a very short reply. 0.93. What is the ratio of the Rate(per 1000 people) of Congo (Democratic) in 2010 to that in 2011?
Offer a very short reply. 1.03. What is the ratio of the Rate(per 1000 people) in Singapore in 2010 to that in 2011?
Provide a short and direct response. 0.98. What is the ratio of the Rate(per 1000 people) of Brazil in 2010 to that in 2012?
Give a very brief answer. 0.99. What is the ratio of the Rate(per 1000 people) of Congo (Democratic) in 2010 to that in 2012?
Your answer should be compact. 1.06. What is the ratio of the Rate(per 1000 people) of Singapore in 2010 to that in 2012?
Your answer should be compact. 0.98. What is the ratio of the Rate(per 1000 people) in Brazil in 2010 to that in 2013?
Your response must be concise. 0.98. What is the ratio of the Rate(per 1000 people) in Congo (Democratic) in 2010 to that in 2013?
Your answer should be very brief. 1.08. What is the ratio of the Rate(per 1000 people) in Singapore in 2010 to that in 2013?
Provide a short and direct response. 0.96. What is the ratio of the Rate(per 1000 people) in Brazil in 2011 to that in 2012?
Offer a very short reply. 0.99. What is the ratio of the Rate(per 1000 people) in Congo (Democratic) in 2011 to that in 2012?
Ensure brevity in your answer.  1.03. What is the ratio of the Rate(per 1000 people) in Congo (Democratic) in 2011 to that in 2013?
Your answer should be very brief. 1.05. What is the ratio of the Rate(per 1000 people) in Singapore in 2011 to that in 2013?
Keep it short and to the point. 0.98. What is the ratio of the Rate(per 1000 people) of Brazil in 2012 to that in 2013?
Ensure brevity in your answer.  0.99. What is the ratio of the Rate(per 1000 people) of Congo (Democratic) in 2012 to that in 2013?
Provide a succinct answer. 1.02. What is the ratio of the Rate(per 1000 people) in Singapore in 2012 to that in 2013?
Make the answer very short. 0.98. What is the difference between the highest and the second highest Rate(per 1000 people) of Brazil?
Provide a short and direct response. 0.04. What is the difference between the highest and the second highest Rate(per 1000 people) in Congo (Democratic)?
Provide a succinct answer. 0.46. What is the difference between the highest and the second highest Rate(per 1000 people) of Singapore?
Your answer should be compact. 0.1. What is the difference between the highest and the lowest Rate(per 1000 people) of Brazil?
Offer a very short reply. 0.19. What is the difference between the highest and the lowest Rate(per 1000 people) in Congo (Democratic)?
Give a very brief answer. 2.48. What is the difference between the highest and the lowest Rate(per 1000 people) in Singapore?
Ensure brevity in your answer.  0.3. 